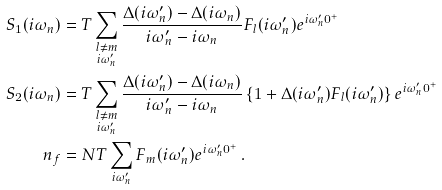Convert formula to latex. <formula><loc_0><loc_0><loc_500><loc_500>S _ { 1 } ( i \omega _ { n } ) & = T \sum _ { \substack { l \neq m \\ i \omega ^ { \prime } _ { n } } } \frac { \Delta ( i \omega ^ { \prime } _ { n } ) - \Delta ( i \omega _ { n } ) } { i \omega ^ { \prime } _ { n } - i \omega _ { n } } F _ { l } ( i \omega ^ { \prime } _ { n } ) e ^ { i \omega ^ { \prime } _ { n } 0 ^ { + } } \\ S _ { 2 } ( i \omega _ { n } ) & = T \sum _ { \substack { l \neq m \\ i \omega ^ { \prime } _ { n } } } \frac { \Delta ( i \omega ^ { \prime } _ { n } ) - \Delta ( i \omega _ { n } ) } { i \omega ^ { \prime } _ { n } - i \omega _ { n } } \left \{ 1 + \Delta ( i \omega ^ { \prime } _ { n } ) F _ { l } ( i \omega ^ { \prime } _ { n } ) \right \} e ^ { i \omega ^ { \prime } _ { n } 0 ^ { + } } \\ n _ { f } & = N T \sum _ { i \omega ^ { \prime } _ { n } } F _ { m } ( i \omega ^ { \prime } _ { n } ) e ^ { i \omega ^ { \prime } _ { n } 0 ^ { + } } \, .</formula> 